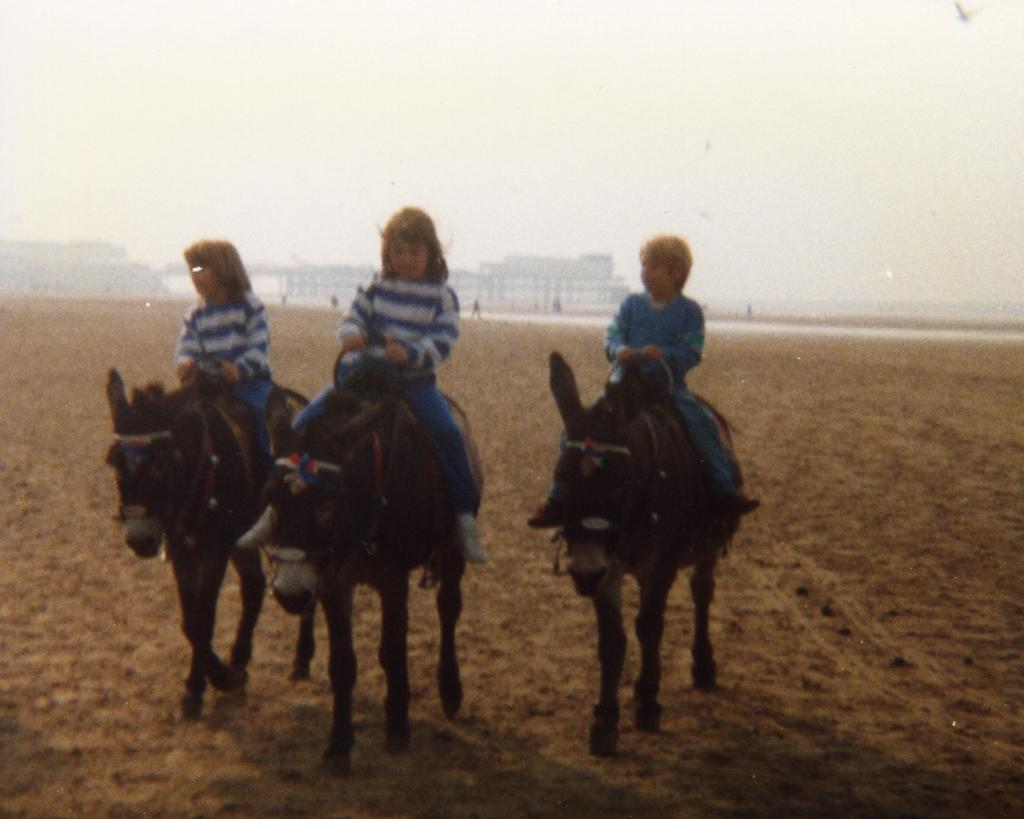How many children are in the image? There are three children in the image. What are the children doing in the image? The children are on horses. What can be seen in the background of the image? There is a building and the sky visible in the background of the image. How many letters are being carried by the mice in the image? There are no mice or letters present in the image. 